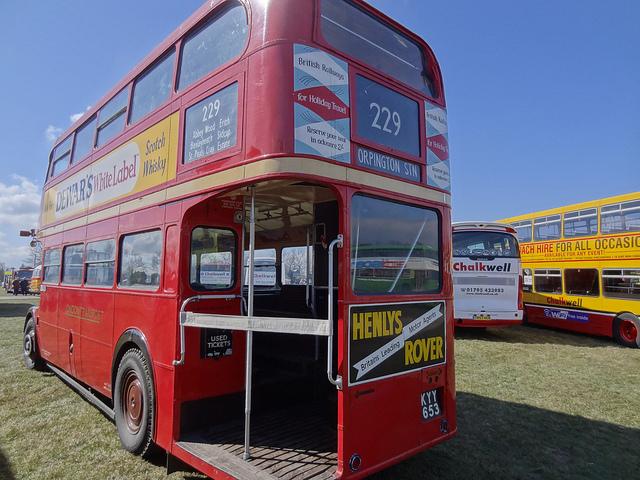What is the number of the bus?
Quick response, please. 229. What is the bus parked on?
Give a very brief answer. Grass. Is the bus top heavy?
Quick response, please. Yes. How many wheels are visible?
Be succinct. 2. What number is on the back and side of the red bus?
Write a very short answer. 229. 